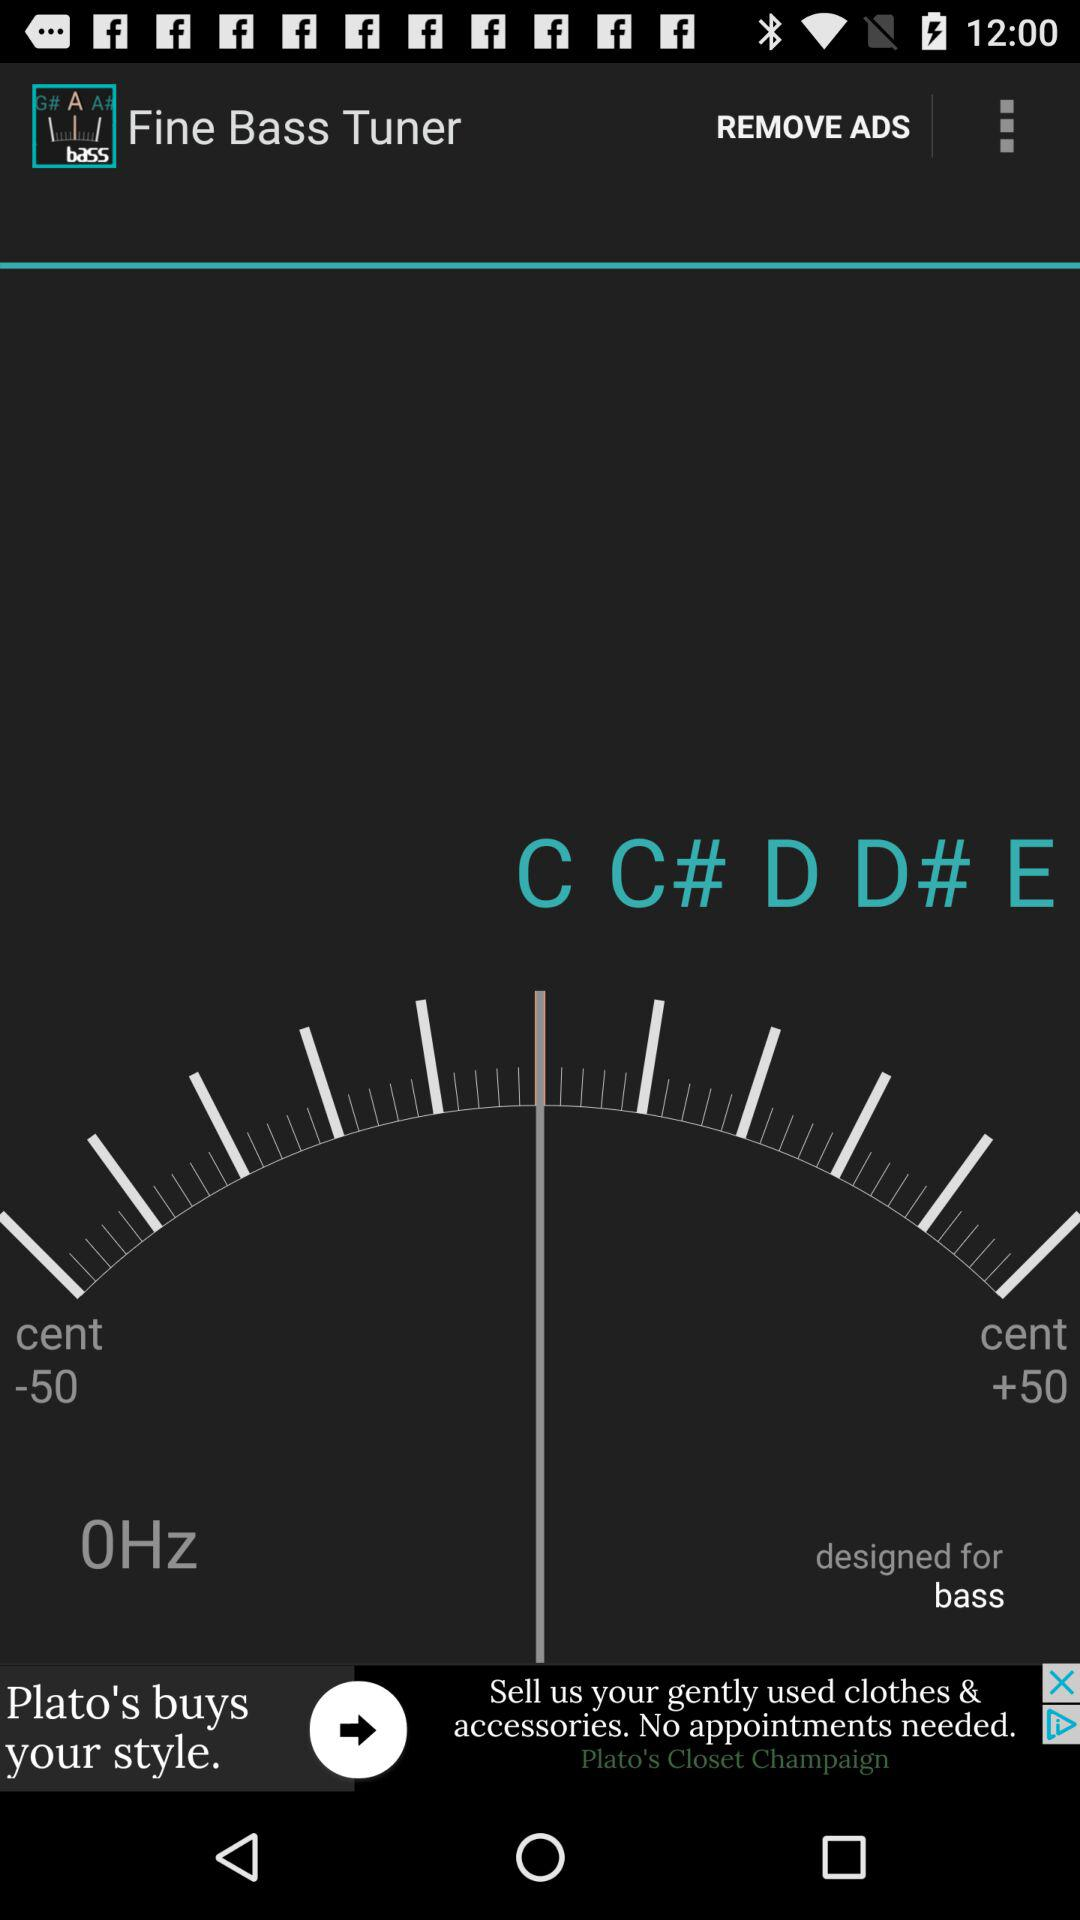What is the name of the application? The name of the application is "Fine Bass Tuner". 